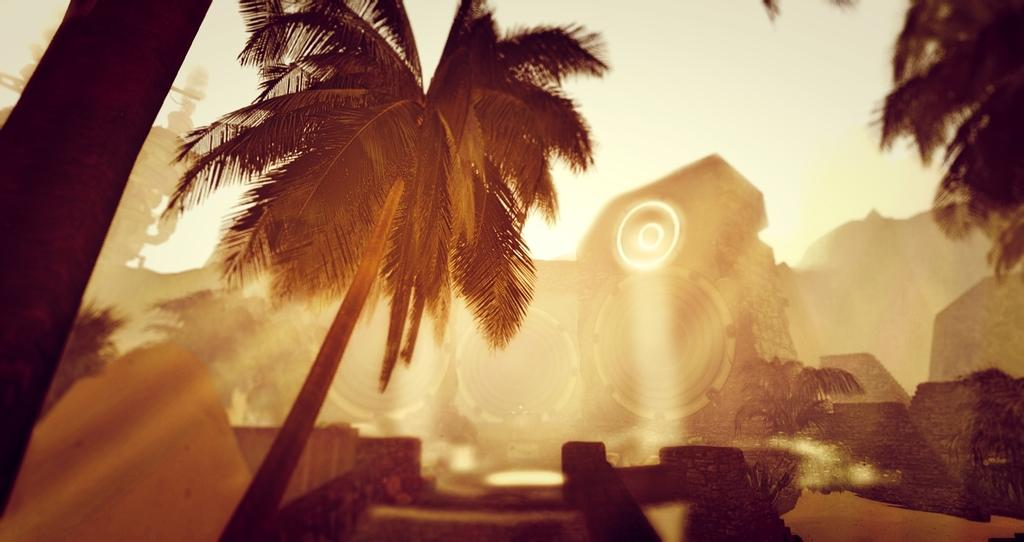What type of vegetation can be seen in the image? There are trees in the image. What is visible in the background of the image? There is a building in the background of the image. What is the condition of the sky in the image? The sky is clear in the image. What is the color scheme of the image? The image is black and white. Can you tell me how many bears are visible in the image? There are no bears present in the image; it features trees and a building. What type of news can be seen in the image? There is no news present in the image; it is a black and white image of trees, a building, and a clear sky. 